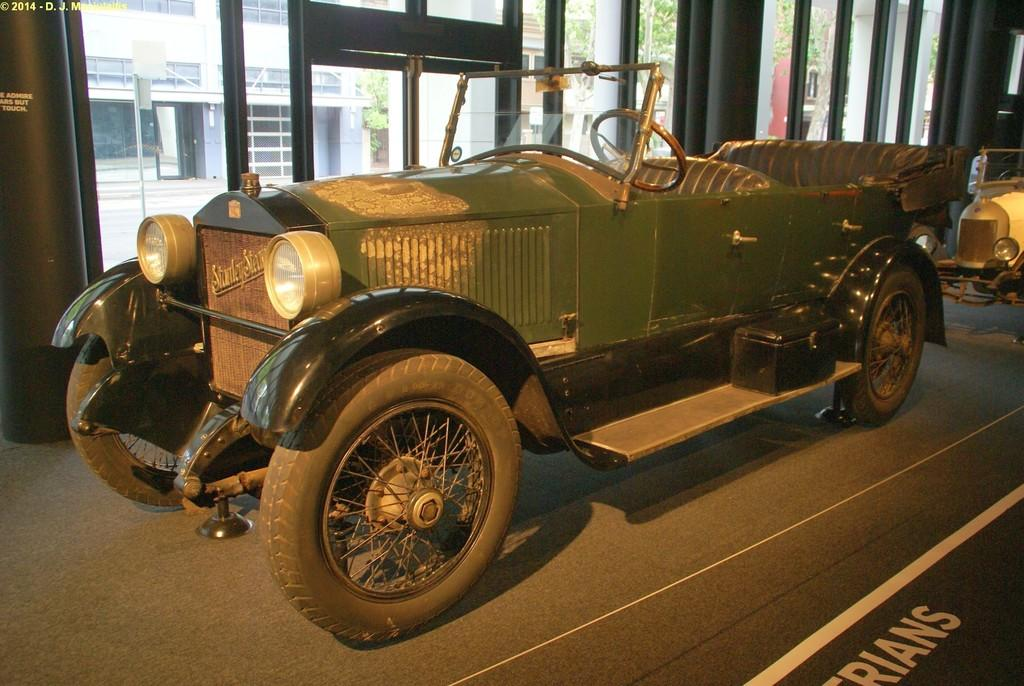How many cars are present in the image? There are two cars in the image. What is the color of one of the cars? One of the cars is green in color. What else can be seen in the image besides the cars? There is a building in the image. What flavor of goat can be seen in the image? There is no goat present in the image, and therefore no flavor can be determined. 